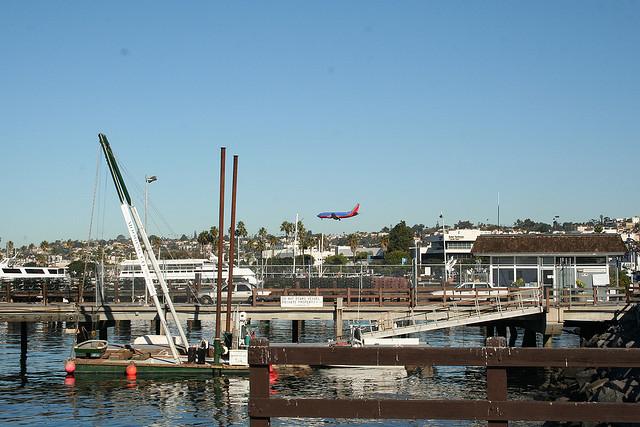What kind of day is this?
Concise answer only. Sunny. How many boats are there?
Keep it brief. 2. Is this a tourist destination?
Answer briefly. Yes. Is the plane flying low?
Be succinct. Yes. What color is the plane flying in the background?
Quick response, please. Blue. 